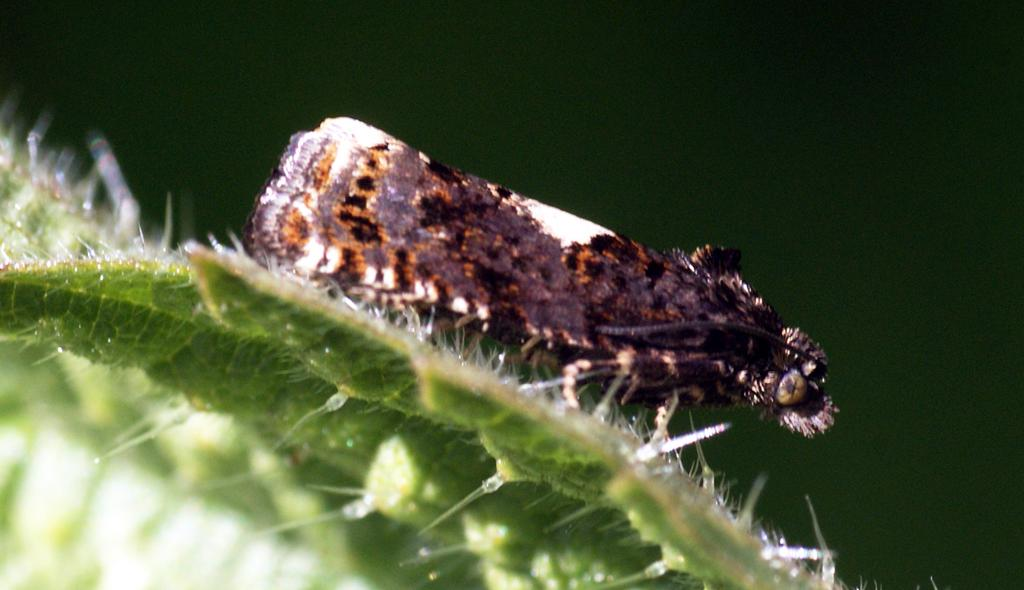What type of natural elements can be seen in the image? There are leaves in the image. What living organism can be found in the image? There is an insect in the image. What can be seen behind the leaves and insect in the image? The background of the image is visible. What is the fifth element in the image? There is no mention of a fifth element in the image, as only leaves and an insect are present. 